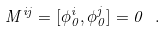Convert formula to latex. <formula><loc_0><loc_0><loc_500><loc_500>M ^ { i j } = [ \phi _ { 0 } ^ { i } , \phi _ { 0 } ^ { j } ] = 0 \ .</formula> 